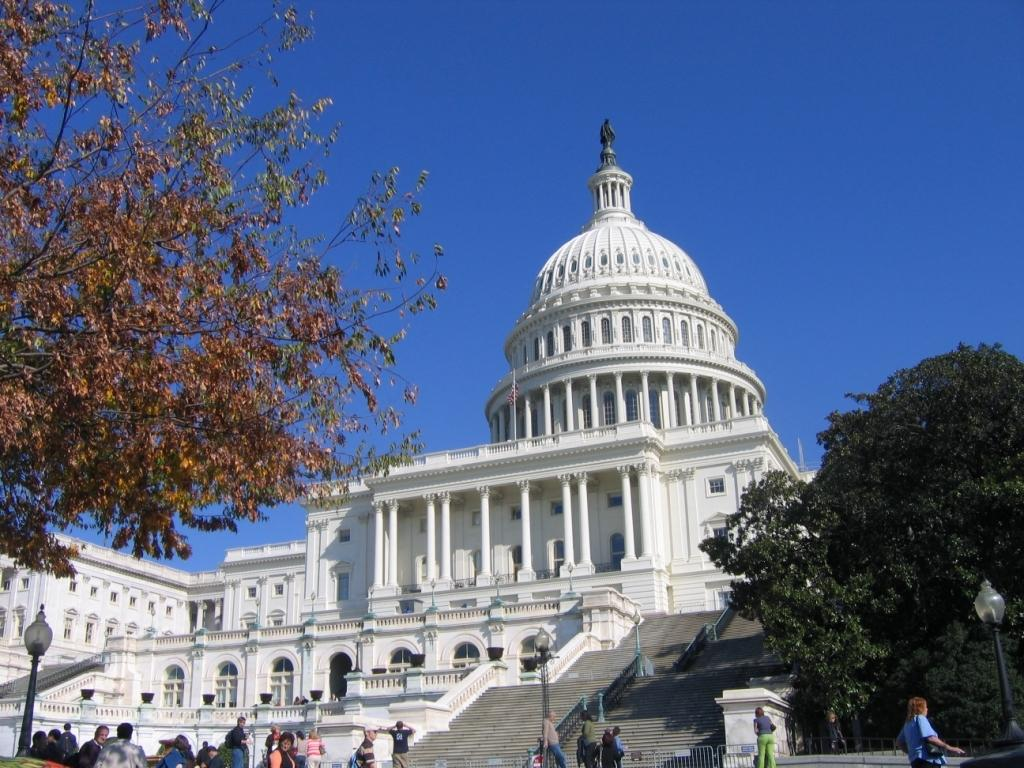What type of structure is in the image? There is a building in the image. What architectural feature is present in the image? There are steps in the image. What are the light poles used for in the image? The light poles are visible in the image, likely for providing illumination. Can you describe the people in the image? There are people in the image, but their specific actions or activities are not mentioned in the facts. What type of barrier is present in the image? A fence is present in the image. What type of vegetation is in the image? Trees are in the image. What can be seen in the background of the image? The background of the image includes a blue sky. What type of lunch is being served to the zebra in the image? There is no zebra present in the image, so no lunch can be served to it. Is there a baseball game happening in the image? There is no mention of a baseball game or any related elements in the image. 